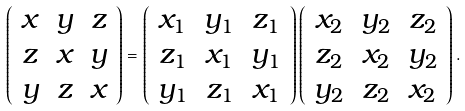Convert formula to latex. <formula><loc_0><loc_0><loc_500><loc_500>\left ( \begin{array} { c c c } x & y & z \\ z & x & y \\ y & z & x \end{array} \right ) = \left ( \begin{array} { c c c } x _ { 1 } & y _ { 1 } & z _ { 1 } \\ z _ { 1 } & x _ { 1 } & y _ { 1 } \\ y _ { 1 } & z _ { 1 } & x _ { 1 } \end{array} \right ) \left ( \begin{array} { c c c } x _ { 2 } & y _ { 2 } & z _ { 2 } \\ z _ { 2 } & x _ { 2 } & y _ { 2 } \\ y _ { 2 } & z _ { 2 } & x _ { 2 } \end{array} \right ) .</formula> 